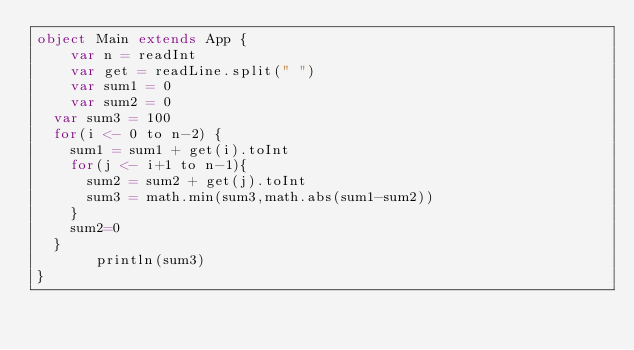Convert code to text. <code><loc_0><loc_0><loc_500><loc_500><_Scala_>object Main extends App {
    var n = readInt
  	var get = readLine.split(" ")
  	var sum1 = 0
  	var sum2 = 0
  var sum3 = 100
  for(i <- 0 to n-2) {
    sum1 = sum1 + get(i).toInt
    for(j <- i+1 to n-1){
      sum2 = sum2 + get(j).toInt
      sum3 = math.min(sum3,math.abs(sum1-sum2))
    }
    sum2=0
  }
       println(sum3)
}</code> 